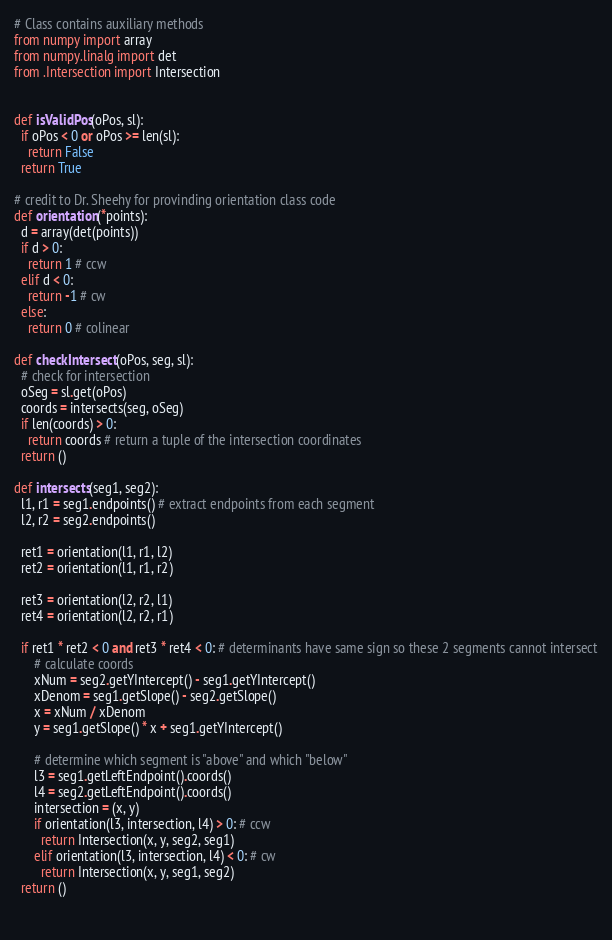Convert code to text. <code><loc_0><loc_0><loc_500><loc_500><_Python_># Class contains auxiliary methods
from numpy import array
from numpy.linalg import det
from .Intersection import Intersection


def isValidPos(oPos, sl):
  if oPos < 0 or oPos >= len(sl):
    return False
  return True

# credit to Dr. Sheehy for provinding orientation class code
def orientation(*points):
  d = array(det(points))
  if d > 0:
    return 1 # ccw
  elif d < 0:
    return -1 # cw
  else:
    return 0 # colinear
  
def checkIntersect(oPos, seg, sl):
  # check for intersection
  oSeg = sl.get(oPos)
  coords = intersects(seg, oSeg)
  if len(coords) > 0:
    return coords # return a tuple of the intersection coordinates
  return ()

def intersects(seg1, seg2):
  l1, r1 = seg1.endpoints() # extract endpoints from each segment
  l2, r2 = seg2.endpoints()
  
  ret1 = orientation(l1, r1, l2)
  ret2 = orientation(l1, r1, r2)
  
  ret3 = orientation(l2, r2, l1)
  ret4 = orientation(l2, r2, r1)
  
  if ret1 * ret2 < 0 and ret3 * ret4 < 0: # determinants have same sign so these 2 segments cannot intersect
      # calculate coords 
      xNum = seg2.getYIntercept() - seg1.getYIntercept()
      xDenom = seg1.getSlope() - seg2.getSlope()
      x = xNum / xDenom
      y = seg1.getSlope() * x + seg1.getYIntercept()
      
      # determine which segment is "above" and which "below"
      l3 = seg1.getLeftEndpoint().coords()
      l4 = seg2.getLeftEndpoint().coords()
      intersection = (x, y)
      if orientation(l3, intersection, l4) > 0: # ccw
        return Intersection(x, y, seg2, seg1)
      elif orientation(l3, intersection, l4) < 0: # cw
        return Intersection(x, y, seg1, seg2)
  return ()
    
    </code> 